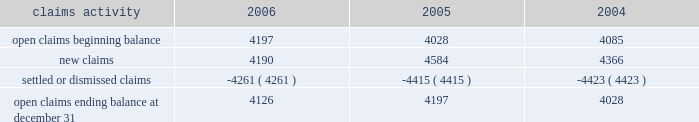Potentially responsible parties , and existing technology , laws , and regulations .
The ultimate liability for remediation is difficult to determine because of the number of potentially responsible parties involved , site- specific cost sharing arrangements with other potentially responsible parties , the degree of contamination by various wastes , the scarcity and quality of volumetric data related to many of the sites , and the speculative nature of remediation costs .
Current obligations are not expected to have a material adverse effect on our consolidated results of operations , financial condition , or liquidity .
Personal injury 2013 the cost of personal injuries to employees and others related to our activities is charged to expense based on estimates of the ultimate cost and number of incidents each year .
We use third-party actuaries to assist us with measuring the expense and liability , including unasserted claims .
The federal employers 2019 liability act ( fela ) governs compensation for work-related accidents .
Under fela , damages are assessed based on a finding of fault through litigation or out-of-court settlements .
We offer a comprehensive variety of services and rehabilitation programs for employees who are injured at work .
Annual expenses for personal injury-related events were $ 240 million in 2006 , $ 247 million in 2005 , and $ 288 million in 2004 .
As of december 31 , 2006 and 2005 , we had accrued liabilities of $ 631 million and $ 619 million for future personal injury costs , respectively , of which $ 233 million and $ 274 million was recorded in current liabilities as accrued casualty costs , respectively .
Our personal injury liability is discounted to present value using applicable u.s .
Treasury rates .
Approximately 87% ( 87 % ) of the recorded liability related to asserted claims , and approximately 13% ( 13 % ) related to unasserted claims .
Estimates can vary over time due to evolving trends in litigation .
Our personal injury claims activity was as follows : claims activity 2006 2005 2004 .
Depreciation 2013 the railroad industry is capital intensive .
Properties are carried at cost .
Provisions for depreciation are computed principally on the straight-line method based on estimated service lives of depreciable property .
The lives are calculated using a separate composite annual percentage rate for each depreciable property group , based on the results of internal depreciation studies .
We are required to submit a report on depreciation studies and proposed depreciation rates to the stb for review and approval every three years for equipment property and every six years for road property .
The cost ( net of salvage ) of depreciable railroad property retired or replaced in the ordinary course of business is charged to accumulated depreciation , and no gain or loss is recognized .
A gain or loss is recognized in other income for all other property upon disposition because the gain or loss is not part of rail operations .
The cost of internally developed software is capitalized and amortized over a five-year period .
Significant capital spending in recent years increased the total value of our depreciable assets .
Cash capital spending totaled $ 2.2 billion for the year ended december 31 , 2006 .
For the year ended december 31 , 2006 , depreciation expense was $ 1.2 billion .
We use various methods to estimate useful lives for each group of depreciable property .
Due to the capital intensive nature of the business and the large base of depreciable assets , variances to those estimates could have a material effect on our consolidated financial statements .
If the estimated useful lives of all depreciable assets were increased by one year , annual depreciation expense would decrease by approximately $ 43 million .
If the estimated useful lives of all assets to be depreciated were decreased by one year , annual depreciation expense would increase by approximately $ 45 million .
Income taxes 2013 as required under fasb statement no .
109 , accounting for income taxes , we account for income taxes by recording taxes payable or refundable for the current year and deferred tax assets and liabilities for the future tax consequences of events that have been recognized in our financial statements or tax returns .
These .
In 2006 what was the ratio of the accrued liabilities to the actual expenses? 
Computations: (631 / 240)
Answer: 2.62917. 